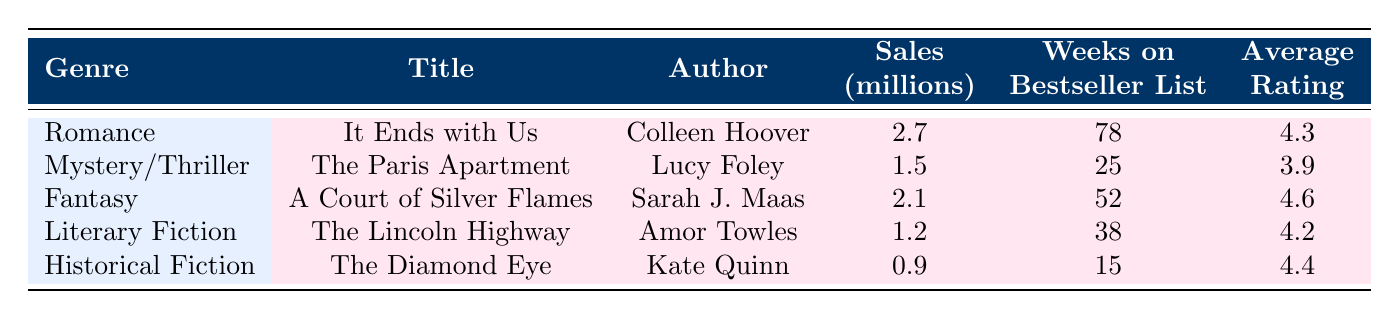What is the title of the bestselling romance book? Looking at the table under the genre "Romance," the title listed is "It Ends with Us."
Answer: It Ends with Us Which book had the highest average rating? The highest average rating can be found by checking the average rating column. "A Court of Silver Flames" has an average rating of 4.6, which is the highest among all listed books.
Answer: A Court of Silver Flames How many weeks did "The Diamond Eye" spend on the bestseller list? Referring to the row for "The Diamond Eye," it spent 15 weeks on the bestseller list.
Answer: 15 What is the total sales in millions for both romance and fantasy genres combined? The sales for Romance "It Ends with Us" is 2.7 million and for Fantasy "A Court of Silver Flames," it is 2.1 million. Adding these together gives 2.7 + 2.1 = 4.8 million.
Answer: 4.8 million Is "The Lincoln Highway" rated higher than "The Paris Apartment"? Comparing the average ratings, "The Lincoln Highway" has an average rating of 4.2 while "The Paris Apartment" has 3.9. Since 4.2 is greater than 3.9, the statement is true.
Answer: Yes Which genre had the lowest sales, and how many millions does it have? By looking at the sales column, the lowest sales figure is 0.9 million which corresponds to Historical Fiction "The Diamond Eye."
Answer: Historical Fiction, 0.9 million How many total weeks did the "Literary Fiction" book stay on the bestseller list? The "Literary Fiction" entry is "The Lincoln Highway," which spent 38 weeks on the bestseller list as noted in the table.
Answer: 38 Can we say that "It Ends with Us" had a high cultural impact? The cultural impact for "It Ends with Us" is labeled as "High," indicating it did indeed have a significant cultural impact.
Answer: Yes What genre had the authors with the highest percentage of cultural impact rated as high? The genres with high cultural impacts are Romance and Fantasy. Out of the five genres listed, two have high cultural impact ratings (40% of the genres).
Answer: Romance and Fantasy 